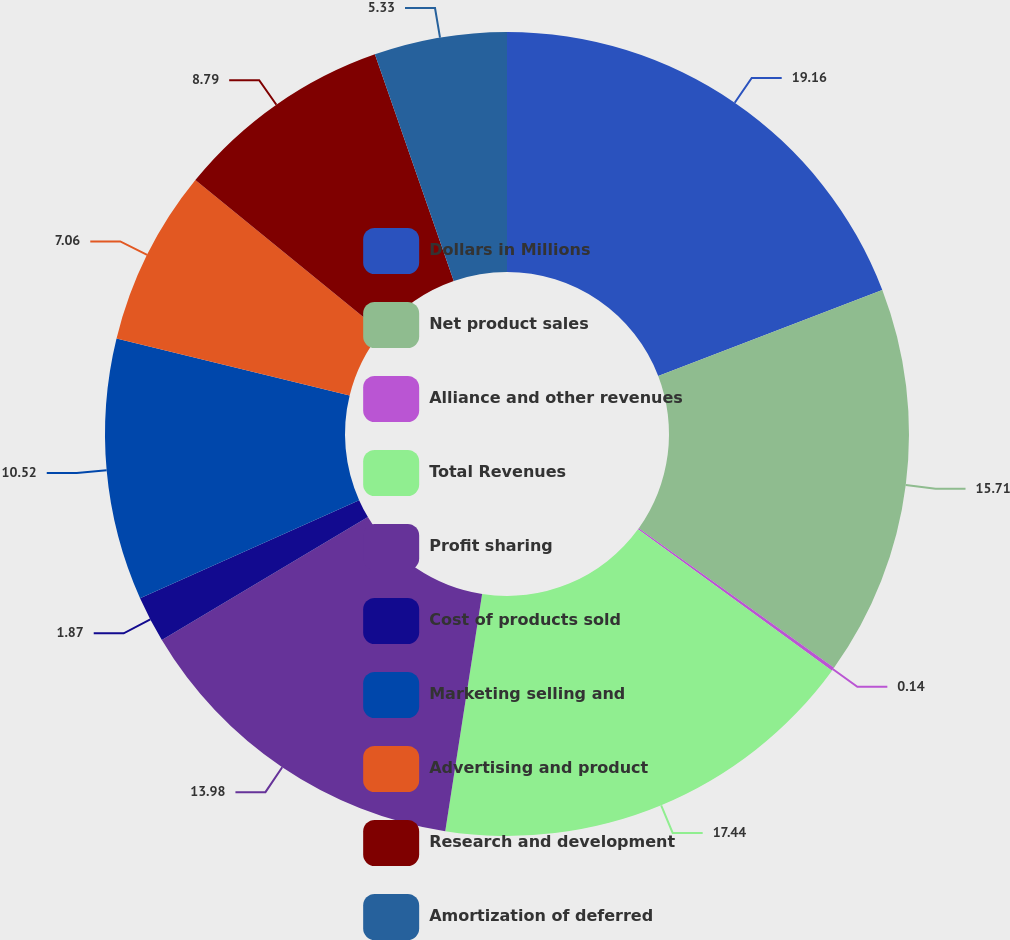<chart> <loc_0><loc_0><loc_500><loc_500><pie_chart><fcel>Dollars in Millions<fcel>Net product sales<fcel>Alliance and other revenues<fcel>Total Revenues<fcel>Profit sharing<fcel>Cost of products sold<fcel>Marketing selling and<fcel>Advertising and product<fcel>Research and development<fcel>Amortization of deferred<nl><fcel>19.17%<fcel>15.71%<fcel>0.14%<fcel>17.44%<fcel>13.98%<fcel>1.87%<fcel>10.52%<fcel>7.06%<fcel>8.79%<fcel>5.33%<nl></chart> 